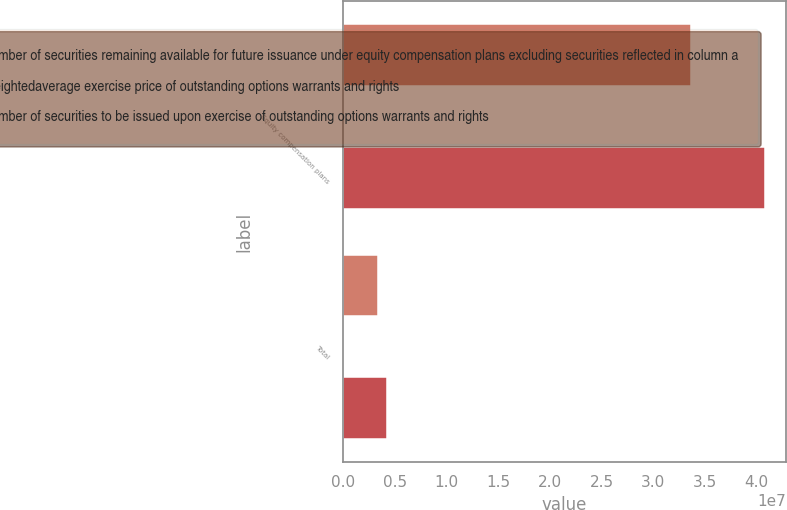<chart> <loc_0><loc_0><loc_500><loc_500><stacked_bar_chart><ecel><fcel>Equity compensation plans<fcel>Total<nl><fcel>Number of securities remaining available for future issuance under equity compensation plans excluding securities reflected in column a<fcel>3.36391e+07<fcel>3.36391e+06<nl><fcel>Weightedaverage exercise price of outstanding options warrants and rights<fcel>37.49<fcel>37.49<nl><fcel>Number of securities to be issued upon exercise of outstanding options warrants and rights<fcel>4.08126e+07<fcel>4.25927e+06<nl></chart> 